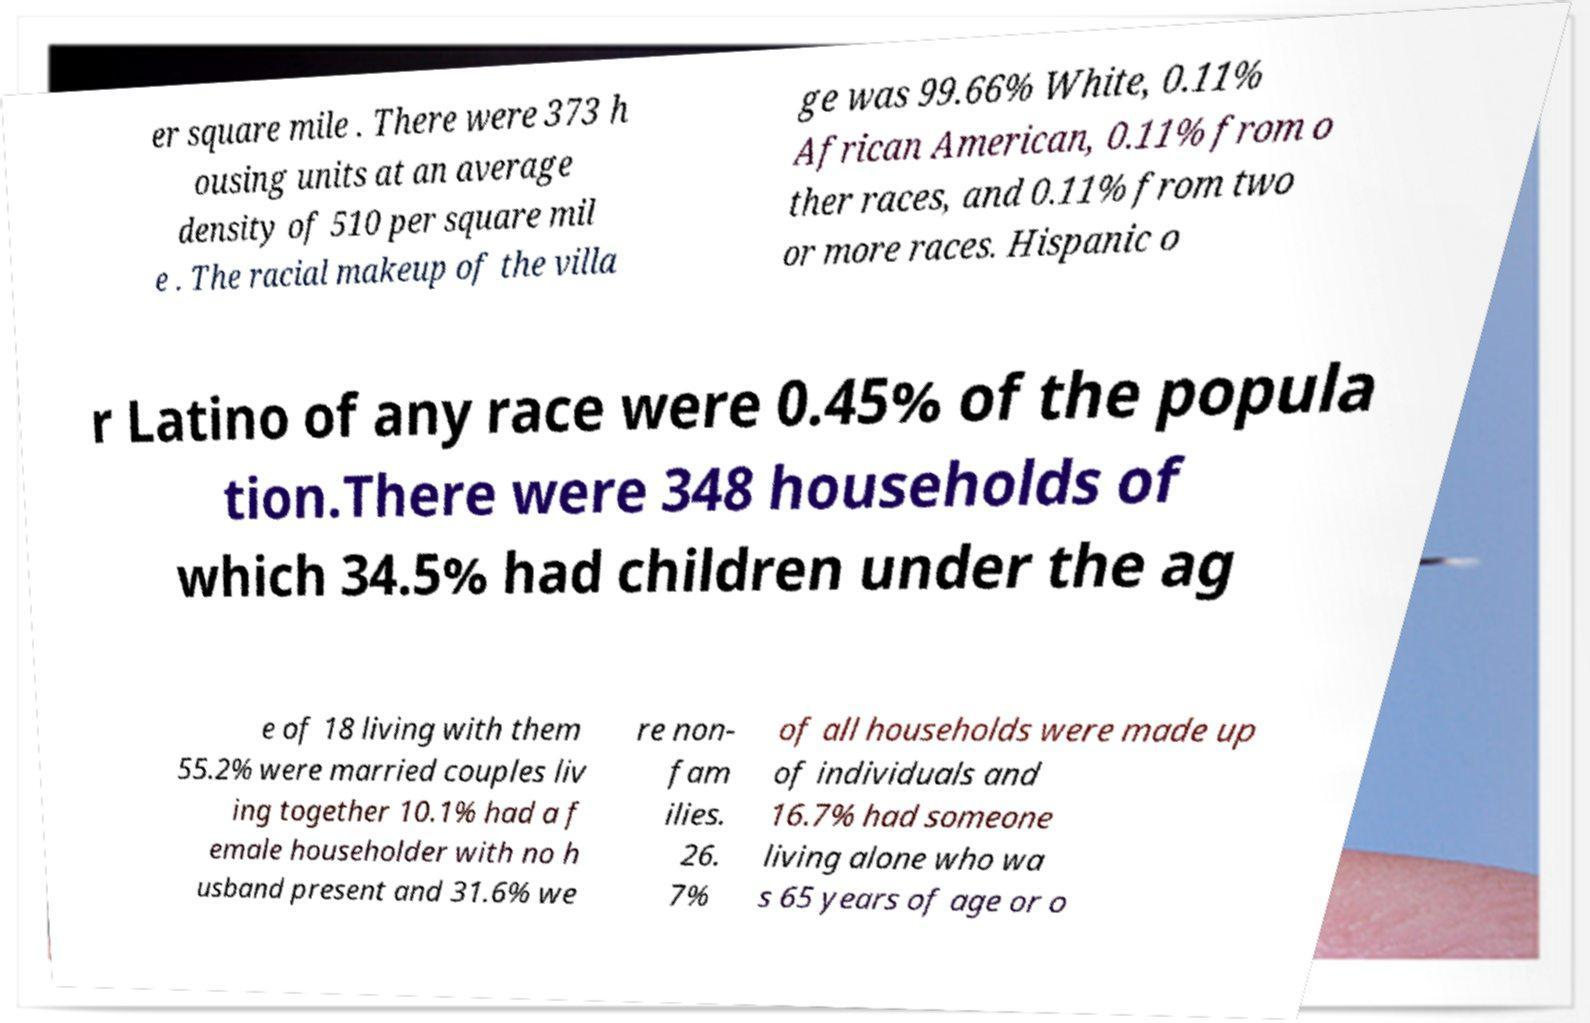There's text embedded in this image that I need extracted. Can you transcribe it verbatim? er square mile . There were 373 h ousing units at an average density of 510 per square mil e . The racial makeup of the villa ge was 99.66% White, 0.11% African American, 0.11% from o ther races, and 0.11% from two or more races. Hispanic o r Latino of any race were 0.45% of the popula tion.There were 348 households of which 34.5% had children under the ag e of 18 living with them 55.2% were married couples liv ing together 10.1% had a f emale householder with no h usband present and 31.6% we re non- fam ilies. 26. 7% of all households were made up of individuals and 16.7% had someone living alone who wa s 65 years of age or o 